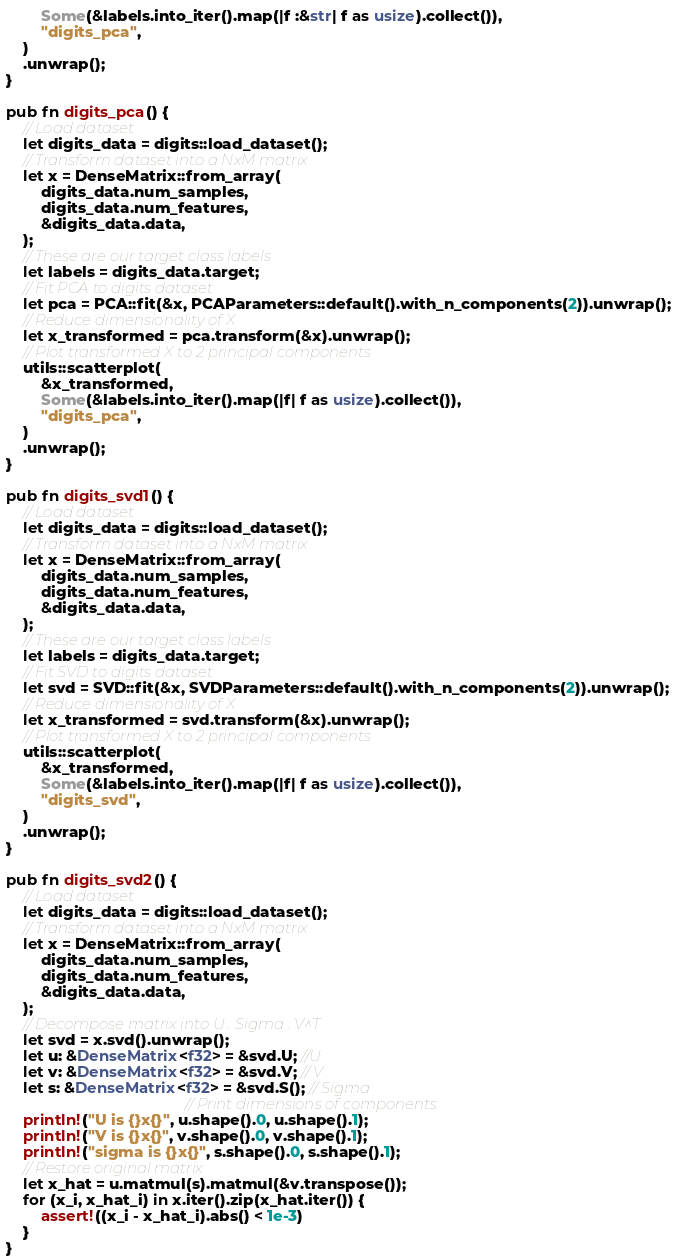<code> <loc_0><loc_0><loc_500><loc_500><_Rust_>        Some(&labels.into_iter().map(|f :&str| f as usize).collect()),
        "digits_pca",
    )
    .unwrap();
}

pub fn digits_pca() {
    // Load dataset
    let digits_data = digits::load_dataset();
    // Transform dataset into a NxM matrix
    let x = DenseMatrix::from_array(
        digits_data.num_samples,
        digits_data.num_features,
        &digits_data.data,
    );
    // These are our target class labels
    let labels = digits_data.target;
    // Fit PCA to digits dataset
    let pca = PCA::fit(&x, PCAParameters::default().with_n_components(2)).unwrap();
    // Reduce dimensionality of X
    let x_transformed = pca.transform(&x).unwrap();
    // Plot transformed X to 2 principal components
    utils::scatterplot(
        &x_transformed,
        Some(&labels.into_iter().map(|f| f as usize).collect()),
        "digits_pca",
    )
    .unwrap();
}

pub fn digits_svd1() {
    // Load dataset
    let digits_data = digits::load_dataset();
    // Transform dataset into a NxM matrix
    let x = DenseMatrix::from_array(
        digits_data.num_samples,
        digits_data.num_features,
        &digits_data.data,
    );
    // These are our target class labels
    let labels = digits_data.target;
    // Fit SVD to digits dataset
    let svd = SVD::fit(&x, SVDParameters::default().with_n_components(2)).unwrap();
    // Reduce dimensionality of X
    let x_transformed = svd.transform(&x).unwrap();
    // Plot transformed X to 2 principal components
    utils::scatterplot(
        &x_transformed,
        Some(&labels.into_iter().map(|f| f as usize).collect()),
        "digits_svd",
    )
    .unwrap();
}

pub fn digits_svd2() {
    // Load dataset
    let digits_data = digits::load_dataset();
    // Transform dataset into a NxM matrix
    let x = DenseMatrix::from_array(
        digits_data.num_samples,
        digits_data.num_features,
        &digits_data.data,
    );
    // Decompose matrix into U . Sigma . V^T
    let svd = x.svd().unwrap();
    let u: &DenseMatrix<f32> = &svd.U; //U
    let v: &DenseMatrix<f32> = &svd.V; // V
    let s: &DenseMatrix<f32> = &svd.S(); // Sigma
                                         // Print dimensions of components
    println!("U is {}x{}", u.shape().0, u.shape().1);
    println!("V is {}x{}", v.shape().0, v.shape().1);
    println!("sigma is {}x{}", s.shape().0, s.shape().1);
    // Restore original matrix
    let x_hat = u.matmul(s).matmul(&v.transpose());
    for (x_i, x_hat_i) in x.iter().zip(x_hat.iter()) {
        assert!((x_i - x_hat_i).abs() < 1e-3)
    }
}
</code> 